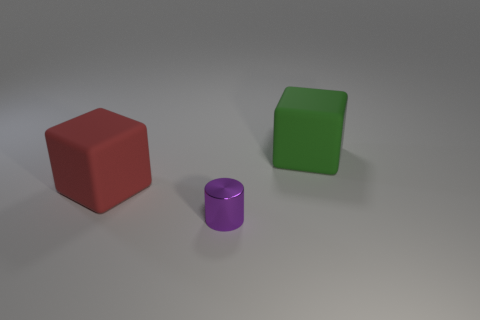Do the cube left of the green object and the small purple object have the same material?
Keep it short and to the point. No. There is a block right of the red matte object; is there a red block that is on the left side of it?
Give a very brief answer. Yes. What material is the other thing that is the same shape as the green matte thing?
Provide a succinct answer. Rubber. Is the number of things that are in front of the small purple metal object greater than the number of purple cylinders that are in front of the large green rubber object?
Make the answer very short. No. The red object that is the same material as the big green block is what shape?
Offer a very short reply. Cube. Are there more red matte cubes to the right of the purple metal cylinder than small cylinders?
Provide a short and direct response. No. Are there more large red matte things than matte objects?
Your response must be concise. No. What material is the tiny purple cylinder?
Keep it short and to the point. Metal. Is the size of the object that is right of the cylinder the same as the tiny purple shiny cylinder?
Your answer should be compact. No. What size is the block left of the green rubber thing?
Ensure brevity in your answer.  Large. 